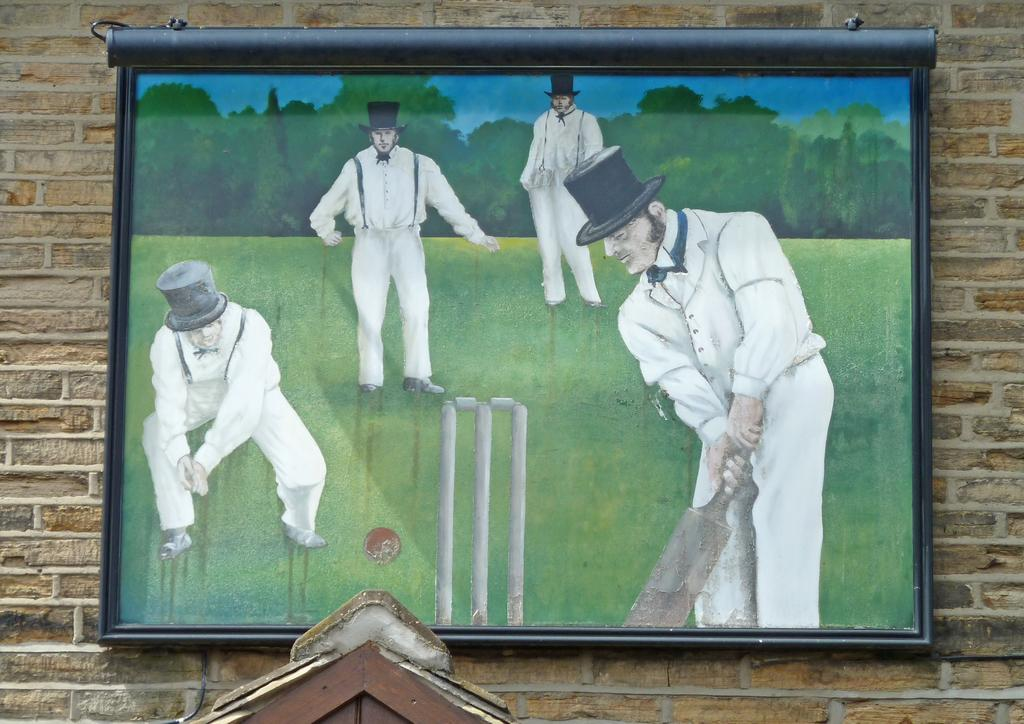What is hanging on the wall in the image? There is a frame on the wall. What is inside the frame? The frame contains a painting. What is happening in the painting? The painting depicts four persons playing on the ground. What objects are present in the painting? There is a ball and a wicket in the painting. What type of natural environment is visible in the painting? There are trees and the sky visible in the painting. How many knots are tied in the painting? There are no knots present in the painting; it depicts persons playing a game with a ball and a wicket. What type of tooth can be seen in the painting? There are no teeth or any dental references in the painting; it focuses on the game being played by the four persons. 